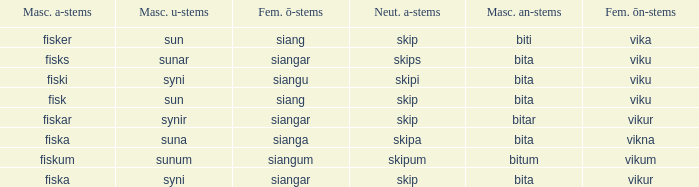What is the u form of the word with a neuter form of skip and a masculine a-ending of fisker? Sun. 